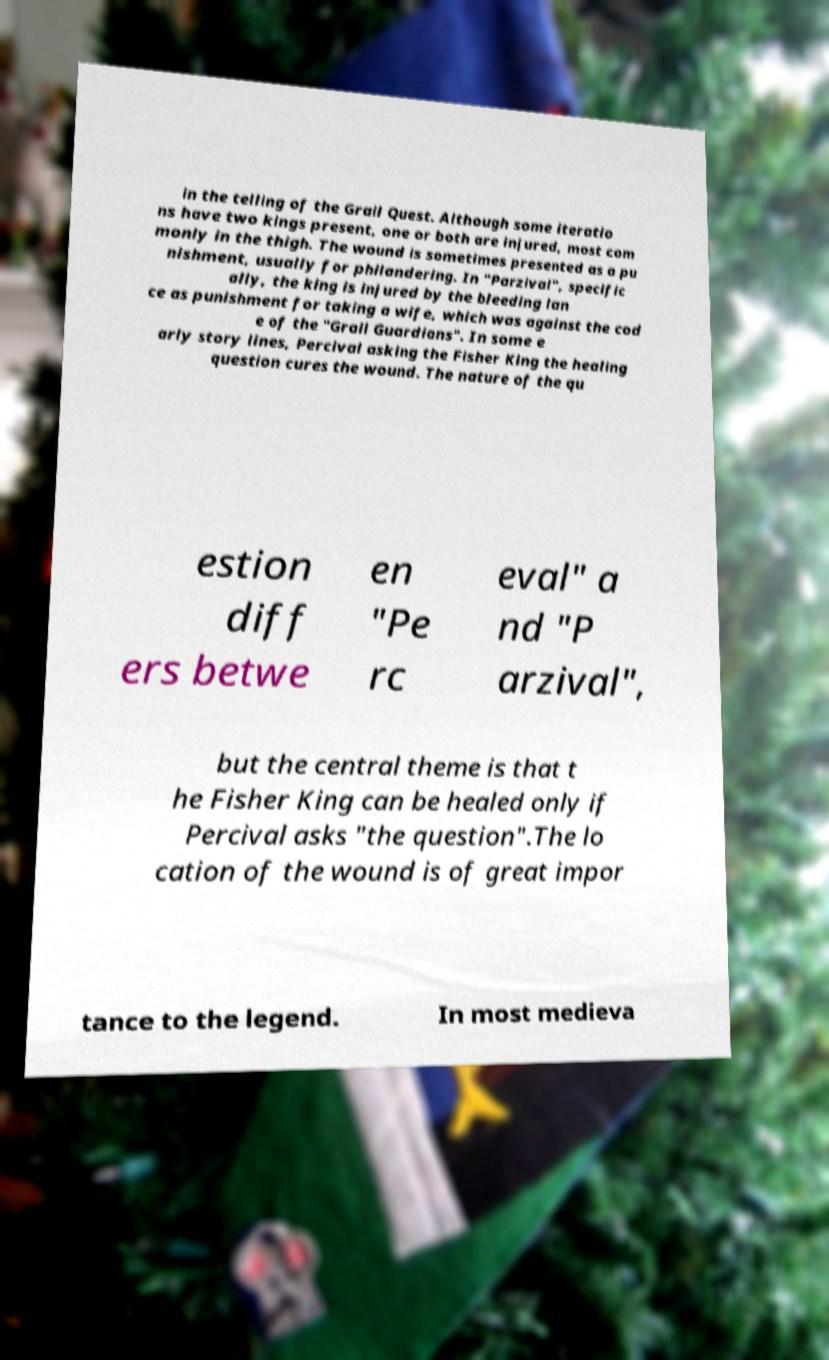Could you extract and type out the text from this image? in the telling of the Grail Quest. Although some iteratio ns have two kings present, one or both are injured, most com monly in the thigh. The wound is sometimes presented as a pu nishment, usually for philandering. In "Parzival", specific ally, the king is injured by the bleeding lan ce as punishment for taking a wife, which was against the cod e of the "Grail Guardians". In some e arly story lines, Percival asking the Fisher King the healing question cures the wound. The nature of the qu estion diff ers betwe en "Pe rc eval" a nd "P arzival", but the central theme is that t he Fisher King can be healed only if Percival asks "the question".The lo cation of the wound is of great impor tance to the legend. In most medieva 